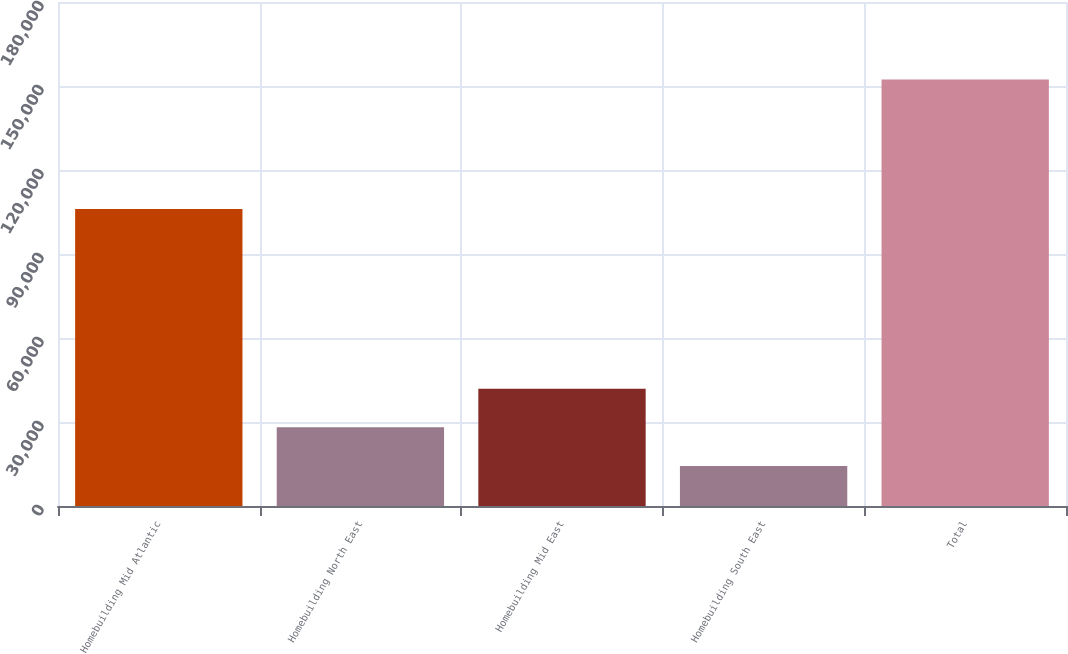Convert chart. <chart><loc_0><loc_0><loc_500><loc_500><bar_chart><fcel>Homebuilding Mid Atlantic<fcel>Homebuilding North East<fcel>Homebuilding Mid East<fcel>Homebuilding South East<fcel>Total<nl><fcel>106032<fcel>28089.2<fcel>41897.4<fcel>14281<fcel>152363<nl></chart> 